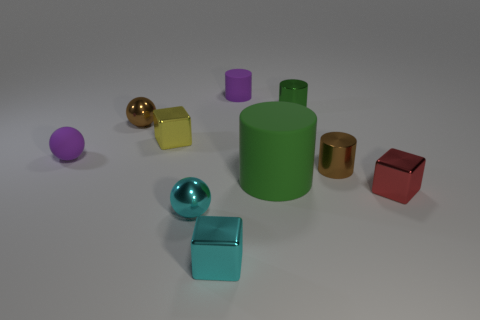Is there anything else that is the same size as the green rubber object?
Give a very brief answer. No. Are there more brown cylinders in front of the small yellow thing than metallic cubes?
Your answer should be compact. No. Are there fewer small yellow blocks on the left side of the small brown shiny ball than small brown metallic spheres?
Make the answer very short. Yes. How many shiny things have the same color as the large matte cylinder?
Provide a short and direct response. 1. What is the cylinder that is both in front of the small green metallic object and behind the green matte cylinder made of?
Your answer should be compact. Metal. There is a small cube that is behind the rubber ball; is it the same color as the big rubber cylinder in front of the tiny brown cylinder?
Your response must be concise. No. What number of brown objects are either rubber things or matte balls?
Give a very brief answer. 0. Are there fewer brown objects to the right of the red metallic thing than red objects that are left of the purple cylinder?
Your answer should be compact. No. Are there any blue metallic balls that have the same size as the red shiny block?
Provide a succinct answer. No. Do the green thing that is in front of the brown ball and the tiny cyan metallic sphere have the same size?
Keep it short and to the point. No. 